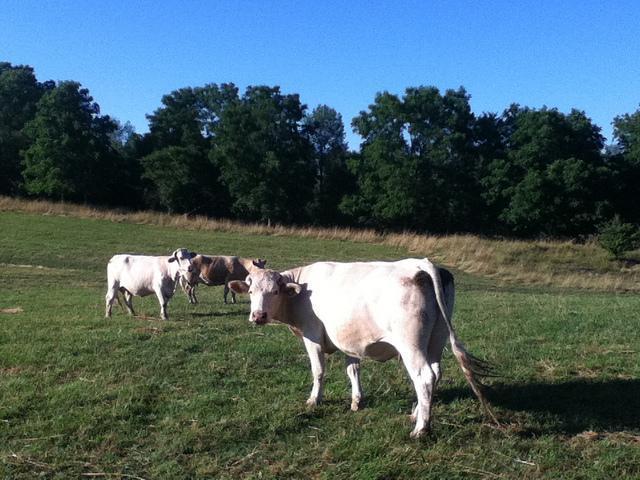How many cows are looking at the camera?
Give a very brief answer. 2. How many cows can be seen?
Give a very brief answer. 3. How many cows are in the picture?
Give a very brief answer. 3. 